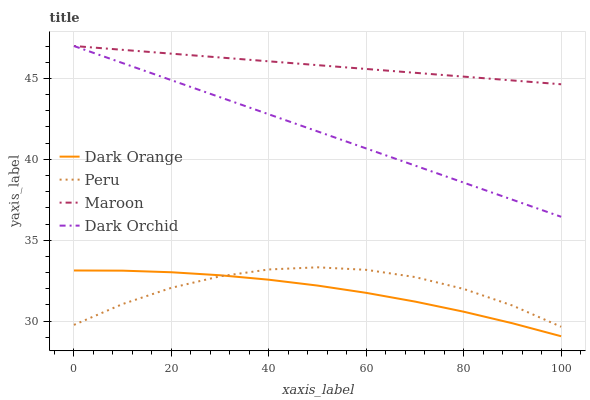Does Dark Orange have the minimum area under the curve?
Answer yes or no. Yes. Does Maroon have the maximum area under the curve?
Answer yes or no. Yes. Does Maroon have the minimum area under the curve?
Answer yes or no. No. Does Dark Orange have the maximum area under the curve?
Answer yes or no. No. Is Dark Orchid the smoothest?
Answer yes or no. Yes. Is Peru the roughest?
Answer yes or no. Yes. Is Dark Orange the smoothest?
Answer yes or no. No. Is Dark Orange the roughest?
Answer yes or no. No. Does Dark Orange have the lowest value?
Answer yes or no. Yes. Does Maroon have the lowest value?
Answer yes or no. No. Does Maroon have the highest value?
Answer yes or no. Yes. Does Dark Orange have the highest value?
Answer yes or no. No. Is Dark Orange less than Maroon?
Answer yes or no. Yes. Is Dark Orchid greater than Peru?
Answer yes or no. Yes. Does Maroon intersect Dark Orchid?
Answer yes or no. Yes. Is Maroon less than Dark Orchid?
Answer yes or no. No. Is Maroon greater than Dark Orchid?
Answer yes or no. No. Does Dark Orange intersect Maroon?
Answer yes or no. No. 